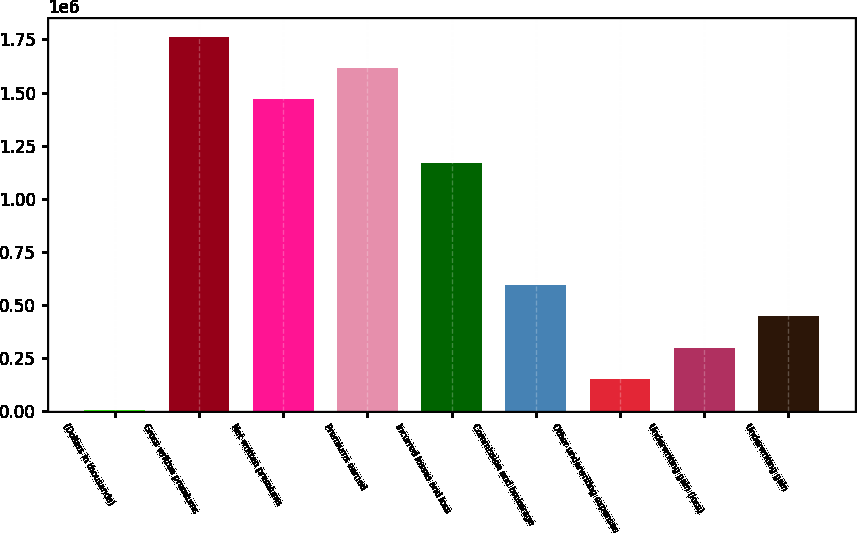Convert chart to OTSL. <chart><loc_0><loc_0><loc_500><loc_500><bar_chart><fcel>(Dollars in thousands)<fcel>Gross written premiums<fcel>Net written premiums<fcel>Premiums earned<fcel>Incurred losses and loss<fcel>Commission and brokerage<fcel>Other underwriting expenses<fcel>Underwriting gain (loss)<fcel>Underwriting gain<nl><fcel>2004<fcel>1.7637e+06<fcel>1.46847e+06<fcel>1.61608e+06<fcel>1.16856e+06<fcel>592466<fcel>149620<fcel>297235<fcel>444850<nl></chart> 